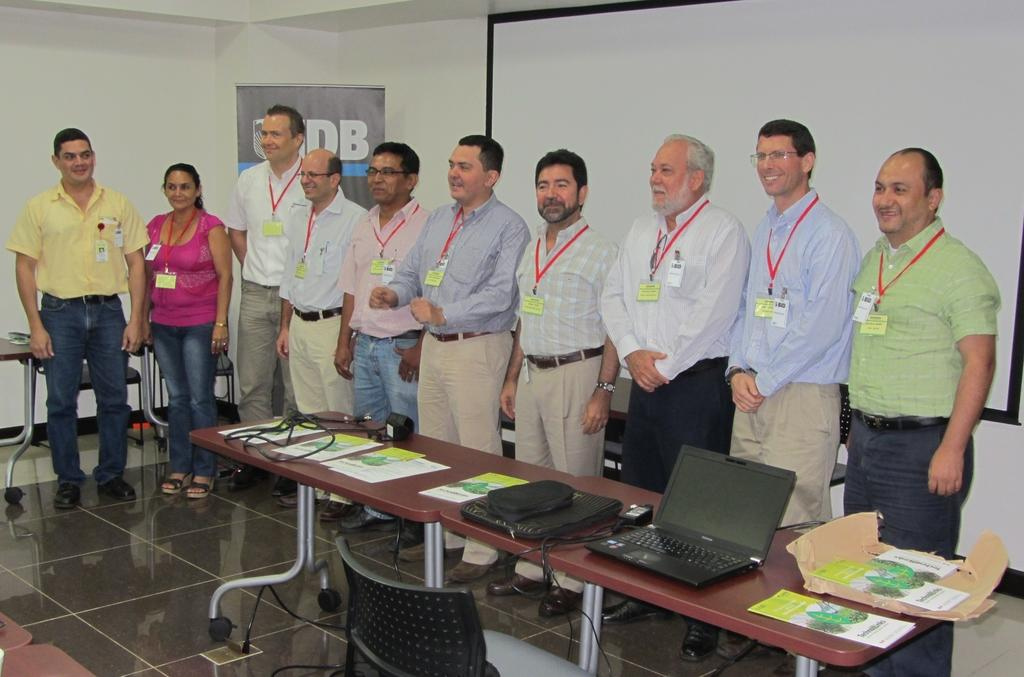What can be observed about the people in the image? There are people standing in the image, and they have smiles on their faces. What objects are present on the table in the image? There is a laptop, a cover, and papers on the table in the image. What type of furniture is in the image? There is a chair in the image. What type of store can be seen in the background of the image? There is no store visible in the image; it only shows people, a table, and a chair. 